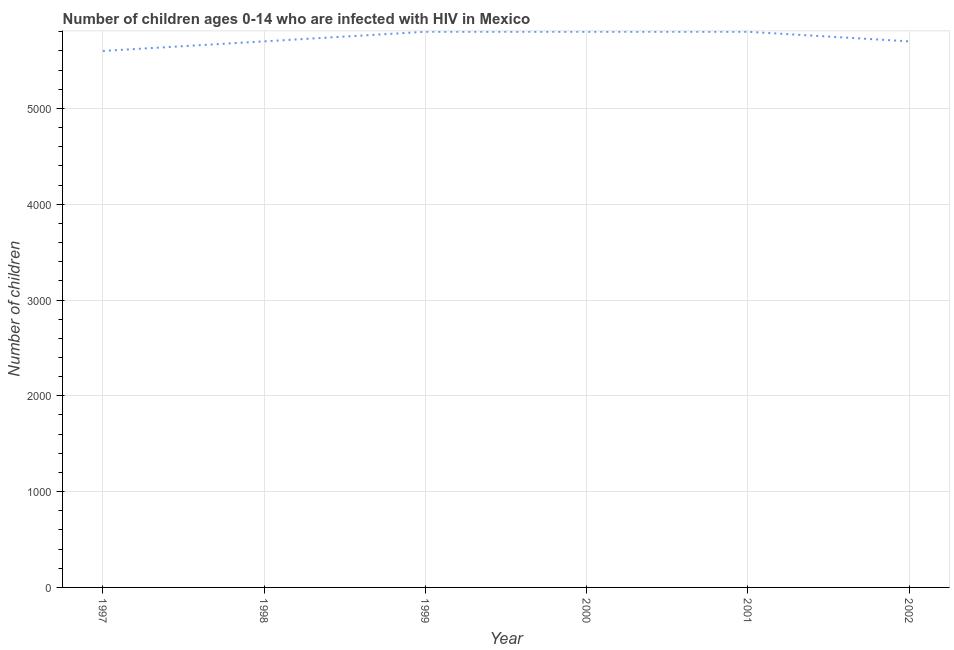What is the number of children living with hiv in 2000?
Your answer should be compact. 5800. Across all years, what is the maximum number of children living with hiv?
Keep it short and to the point. 5800. Across all years, what is the minimum number of children living with hiv?
Keep it short and to the point. 5600. In which year was the number of children living with hiv maximum?
Your response must be concise. 1999. What is the sum of the number of children living with hiv?
Keep it short and to the point. 3.44e+04. What is the difference between the number of children living with hiv in 1999 and 2001?
Keep it short and to the point. 0. What is the average number of children living with hiv per year?
Offer a terse response. 5733.33. What is the median number of children living with hiv?
Make the answer very short. 5750. In how many years, is the number of children living with hiv greater than 400 ?
Ensure brevity in your answer.  6. What is the ratio of the number of children living with hiv in 1998 to that in 1999?
Give a very brief answer. 0.98. Is the number of children living with hiv in 1999 less than that in 2001?
Give a very brief answer. No. Is the sum of the number of children living with hiv in 1999 and 2002 greater than the maximum number of children living with hiv across all years?
Give a very brief answer. Yes. What is the difference between the highest and the lowest number of children living with hiv?
Give a very brief answer. 200. In how many years, is the number of children living with hiv greater than the average number of children living with hiv taken over all years?
Give a very brief answer. 3. Does the number of children living with hiv monotonically increase over the years?
Offer a terse response. No. Does the graph contain any zero values?
Your answer should be very brief. No. What is the title of the graph?
Your answer should be very brief. Number of children ages 0-14 who are infected with HIV in Mexico. What is the label or title of the Y-axis?
Ensure brevity in your answer.  Number of children. What is the Number of children of 1997?
Offer a terse response. 5600. What is the Number of children of 1998?
Your answer should be very brief. 5700. What is the Number of children in 1999?
Provide a short and direct response. 5800. What is the Number of children of 2000?
Your response must be concise. 5800. What is the Number of children of 2001?
Offer a terse response. 5800. What is the Number of children of 2002?
Make the answer very short. 5700. What is the difference between the Number of children in 1997 and 1998?
Offer a very short reply. -100. What is the difference between the Number of children in 1997 and 1999?
Offer a very short reply. -200. What is the difference between the Number of children in 1997 and 2000?
Your answer should be very brief. -200. What is the difference between the Number of children in 1997 and 2001?
Offer a very short reply. -200. What is the difference between the Number of children in 1997 and 2002?
Make the answer very short. -100. What is the difference between the Number of children in 1998 and 1999?
Provide a short and direct response. -100. What is the difference between the Number of children in 1998 and 2000?
Ensure brevity in your answer.  -100. What is the difference between the Number of children in 1998 and 2001?
Make the answer very short. -100. What is the difference between the Number of children in 1999 and 2000?
Provide a succinct answer. 0. What is the difference between the Number of children in 1999 and 2001?
Your answer should be very brief. 0. What is the difference between the Number of children in 1999 and 2002?
Your response must be concise. 100. What is the difference between the Number of children in 2000 and 2001?
Provide a succinct answer. 0. What is the difference between the Number of children in 2000 and 2002?
Offer a terse response. 100. What is the difference between the Number of children in 2001 and 2002?
Offer a very short reply. 100. What is the ratio of the Number of children in 1997 to that in 1998?
Your response must be concise. 0.98. What is the ratio of the Number of children in 1997 to that in 1999?
Provide a succinct answer. 0.97. What is the ratio of the Number of children in 1997 to that in 2000?
Make the answer very short. 0.97. What is the ratio of the Number of children in 1997 to that in 2001?
Give a very brief answer. 0.97. What is the ratio of the Number of children in 1997 to that in 2002?
Offer a very short reply. 0.98. What is the ratio of the Number of children in 1998 to that in 2002?
Make the answer very short. 1. What is the ratio of the Number of children in 1999 to that in 2002?
Keep it short and to the point. 1.02. What is the ratio of the Number of children in 2000 to that in 2001?
Ensure brevity in your answer.  1. 